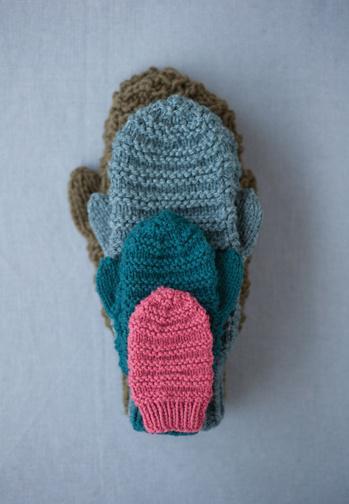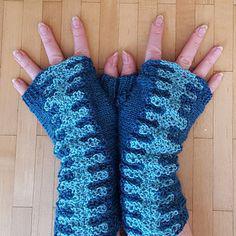The first image is the image on the left, the second image is the image on the right. Analyze the images presented: Is the assertion "A pair of gloves is being worn on a set of hands in the image on the left." valid? Answer yes or no. No. The first image is the image on the left, the second image is the image on the right. Considering the images on both sides, is "The left image contains a human wearing blue gloves that have the finger tips cut off." valid? Answer yes or no. No. 